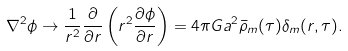Convert formula to latex. <formula><loc_0><loc_0><loc_500><loc_500>\nabla ^ { 2 } \phi \to \frac { 1 } { r ^ { 2 } } \frac { \partial } { \partial r } \left ( r ^ { 2 } \frac { \partial \phi } { \partial r } \right ) = 4 \pi G a ^ { 2 } \bar { \rho } _ { m } ( \tau ) \delta _ { m } ( r , \tau ) .</formula> 